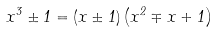<formula> <loc_0><loc_0><loc_500><loc_500>x ^ { 3 } \pm 1 = ( x \pm 1 ) \left ( x ^ { 2 } \mp x + 1 \right )</formula> 